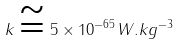<formula> <loc_0><loc_0><loc_500><loc_500>k \cong 5 \times 1 0 ^ { - 6 5 } W . k g ^ { - 3 }</formula> 